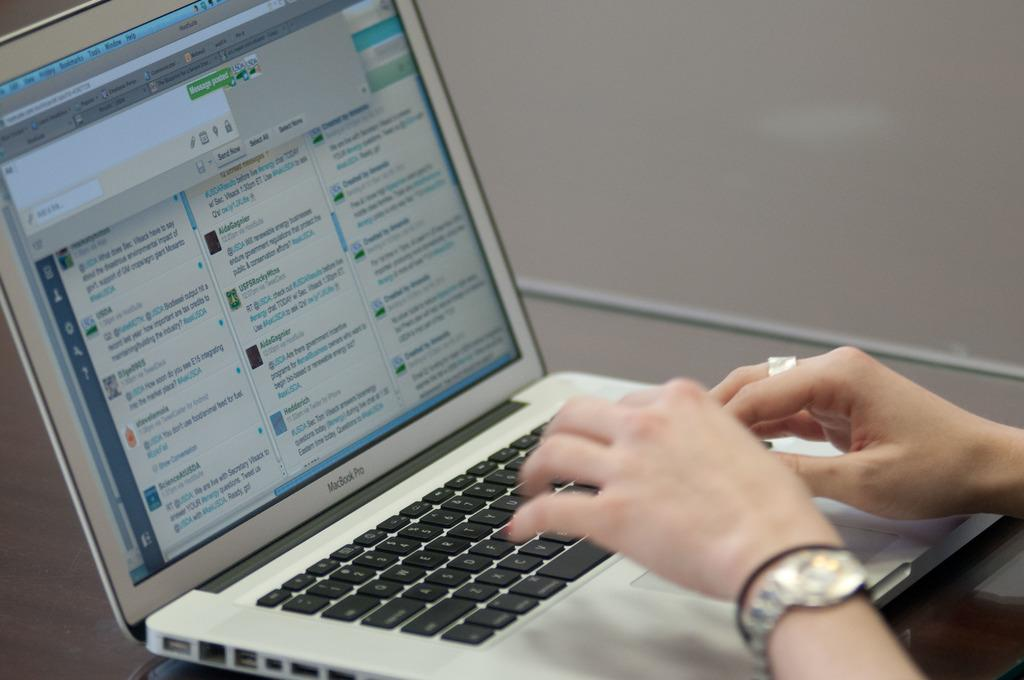What is the main object in the center of the image? There is a laptop in the center of the image. What can be seen on the right side of the image? There are hands of a person on the right side of the image. What information is displayed on the laptop screen? There is text displayed on the screen of the laptop. What type of cough can be heard coming from the person in the image? There is no sound or indication of a cough in the image, so it cannot be determined. 